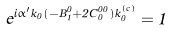<formula> <loc_0><loc_0><loc_500><loc_500>e ^ { i \alpha ^ { \prime } k _ { 0 } ( - B _ { 1 } ^ { 0 } + 2 C _ { 0 } ^ { 0 0 } ) k _ { 0 } ^ { ( c ) } } = 1</formula> 